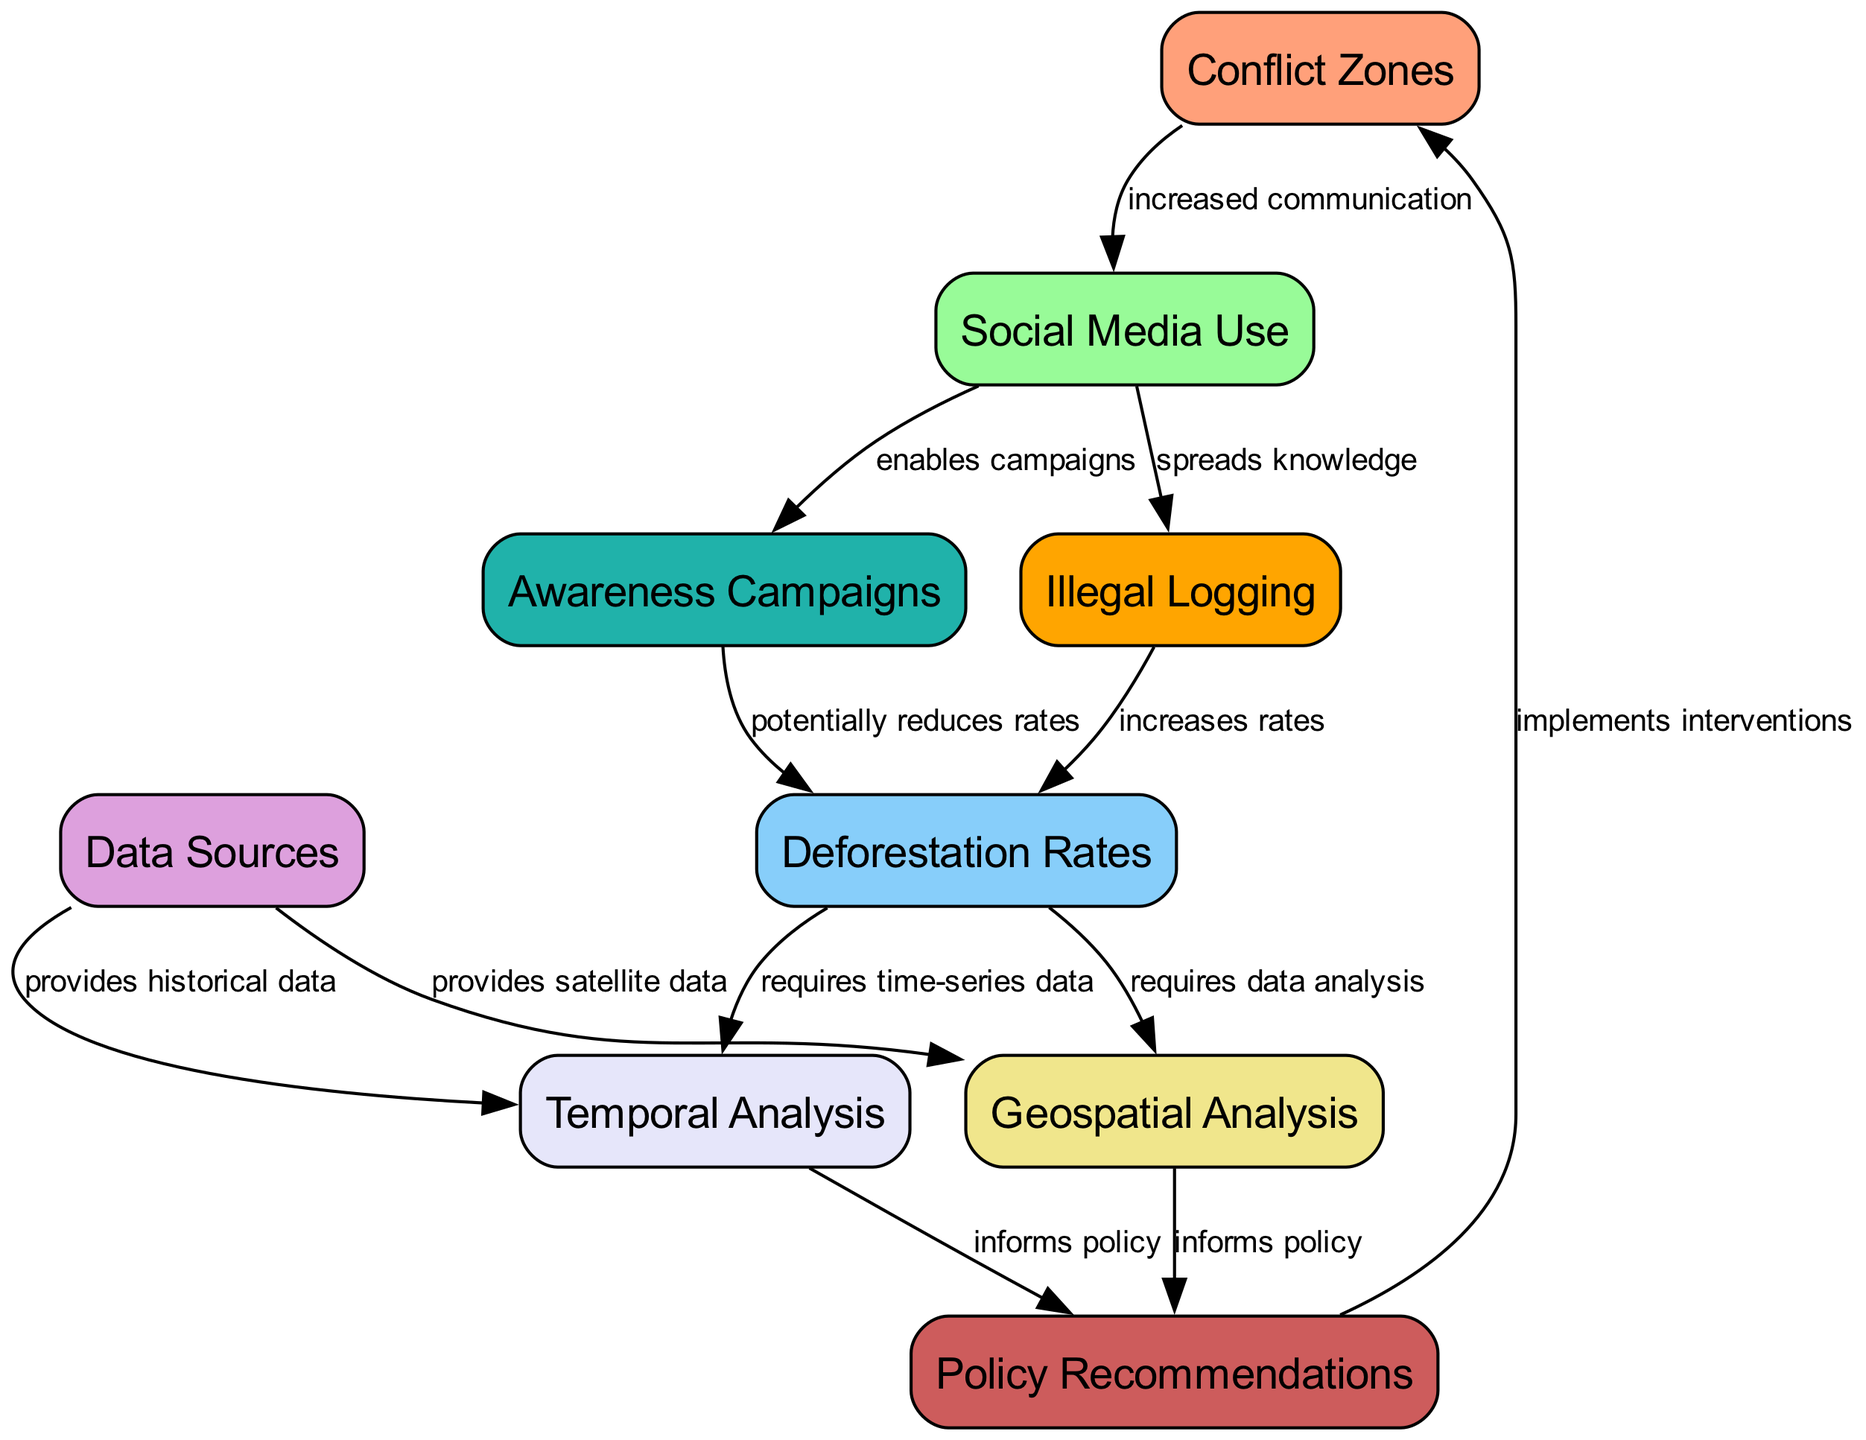What are the nodes present in the diagram? The diagram lists several nodes: Conflict Zones, Social Media Use, Deforestation Rates, Data Sources, Geospatial Analysis, Temporal Analysis, Awareness Campaigns, Illegal Logging, and Policy Recommendations are all present.
Answer: Conflict Zones, Social Media Use, Deforestation Rates, Data Sources, Geospatial Analysis, Temporal Analysis, Awareness Campaigns, Illegal Logging, Policy Recommendations How many edges does the diagram have? By counting the connections (relationships) between the nodes in the diagram, we find that there are 12 edges connecting these nodes.
Answer: 12 What relationship exists between Social Media Use and Awareness Campaigns? According to the diagram, the edge connecting these nodes is labeled "enables campaigns," indicating that social media use helps facilitate awareness campaigns.
Answer: enables campaigns Which node provides satellite data for geospatial analysis? The diagram indicates that Data Sources is the node responsible for providing satellite data, as shown by the arrow connecting these two nodes.
Answer: Data Sources How does Illegal Logging affect Deforestation Rates? The diagram states that Illegal Logging leads to an increase in Deforestation Rates through the directed edge labeled "increases rates," showing a clear causal relationship.
Answer: increases rates What role does Temporal Analysis play in relation to Policy Recommendations? The edge connecting Temporal Analysis to Policy Recommendations signifies that Temporal Analysis informs policy, indicating that historical data is crucial for policy decisions on deforestation.
Answer: informs policy If social media use spreads knowledge about illegal logging, what is its overall effect on deforestation rates, based on the diagram? The diagram presents a dual relationship: while social media use contributes to spreading knowledge about illegal logging (which increases deforestation rates), it also enables awareness campaigns that can potentially reduce these rates. This complexity shows how it can lead to both positive and negative impacts.
Answer: both increases and potentially reduces rates Which node is responsible for implementing interventions in conflict zones? The edge that points from Policy Recommendations to Conflict Zones indicates that Policy Recommendations are the driving force behind implementing interventions in these areas.
Answer: Policy Recommendations 